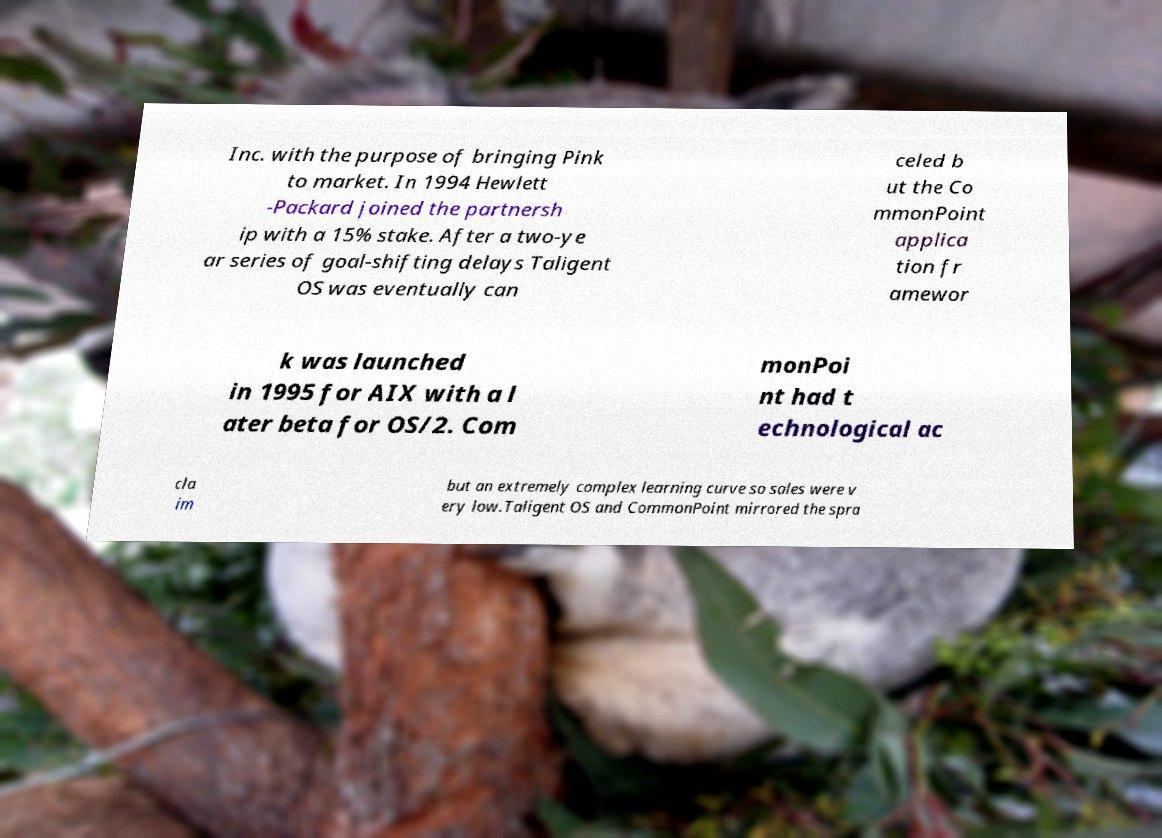Can you read and provide the text displayed in the image?This photo seems to have some interesting text. Can you extract and type it out for me? Inc. with the purpose of bringing Pink to market. In 1994 Hewlett -Packard joined the partnersh ip with a 15% stake. After a two-ye ar series of goal-shifting delays Taligent OS was eventually can celed b ut the Co mmonPoint applica tion fr amewor k was launched in 1995 for AIX with a l ater beta for OS/2. Com monPoi nt had t echnological ac cla im but an extremely complex learning curve so sales were v ery low.Taligent OS and CommonPoint mirrored the spra 